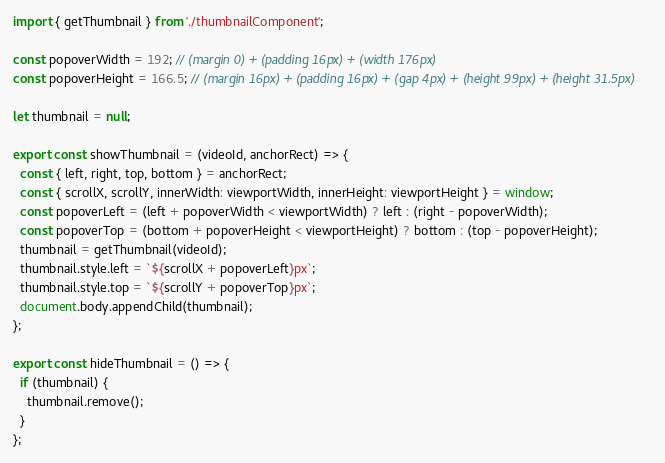<code> <loc_0><loc_0><loc_500><loc_500><_JavaScript_>import { getThumbnail } from './thumbnailComponent';

const popoverWidth = 192; // (margin 0) + (padding 16px) + (width 176px)
const popoverHeight = 166.5; // (margin 16px) + (padding 16px) + (gap 4px) + (height 99px) + (height 31.5px)

let thumbnail = null;

export const showThumbnail = (videoId, anchorRect) => {
  const { left, right, top, bottom } = anchorRect;
  const { scrollX, scrollY, innerWidth: viewportWidth, innerHeight: viewportHeight } = window;
  const popoverLeft = (left + popoverWidth < viewportWidth) ? left : (right - popoverWidth);
  const popoverTop = (bottom + popoverHeight < viewportHeight) ? bottom : (top - popoverHeight);
  thumbnail = getThumbnail(videoId);
  thumbnail.style.left = `${scrollX + popoverLeft}px`;
  thumbnail.style.top = `${scrollY + popoverTop}px`;
  document.body.appendChild(thumbnail);
};

export const hideThumbnail = () => {
  if (thumbnail) {
    thumbnail.remove();
  }
};
</code> 